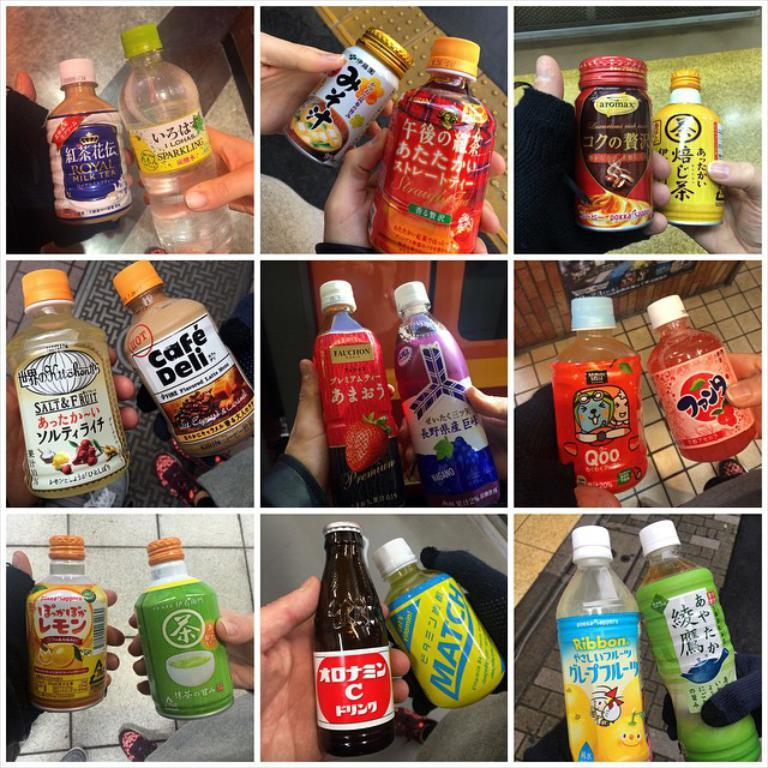<image>
Offer a succinct explanation of the picture presented. A collage of several pictures of bottled drinks includes Cafe Deli, Match, and Ribbon. 